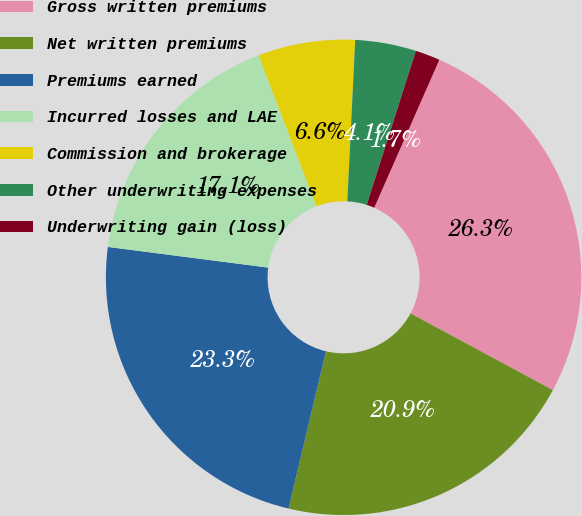Convert chart. <chart><loc_0><loc_0><loc_500><loc_500><pie_chart><fcel>Gross written premiums<fcel>Net written premiums<fcel>Premiums earned<fcel>Incurred losses and LAE<fcel>Commission and brokerage<fcel>Other underwriting expenses<fcel>Underwriting gain (loss)<nl><fcel>26.27%<fcel>20.86%<fcel>23.32%<fcel>17.14%<fcel>6.6%<fcel>4.14%<fcel>1.68%<nl></chart> 